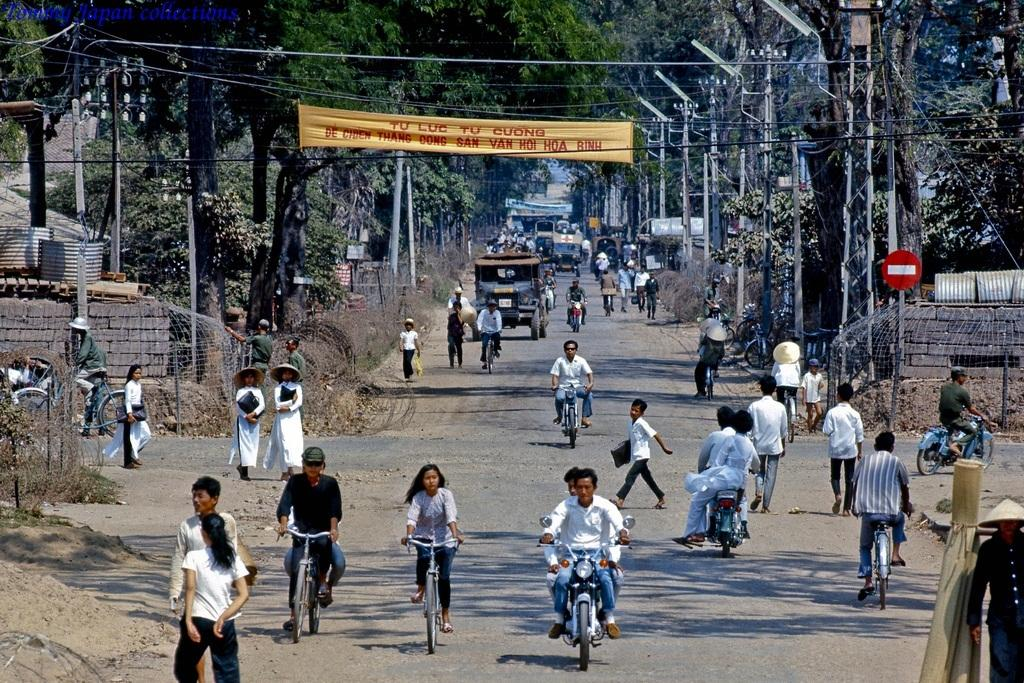How many modes of transportation can be seen in the image? In the image, people are walking, riding bicycles, and riding motorcycles, so there are three modes of transportation visible. What is the natural element visible in the background? There is a tree visible in the background. What else can be seen in the background besides the tree? There is a vehicle and a poster visible in the background. What is the weight of the crack on the road in the image? There is no crack on the road in the image, so it is not possible to determine its weight. 